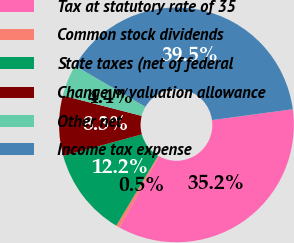<chart> <loc_0><loc_0><loc_500><loc_500><pie_chart><fcel>Tax at statutory rate of 35<fcel>Common stock dividends<fcel>State taxes (net of federal<fcel>Change in valuation allowance<fcel>Other net<fcel>Income tax expense<nl><fcel>35.21%<fcel>0.49%<fcel>12.18%<fcel>8.28%<fcel>4.38%<fcel>39.46%<nl></chart> 